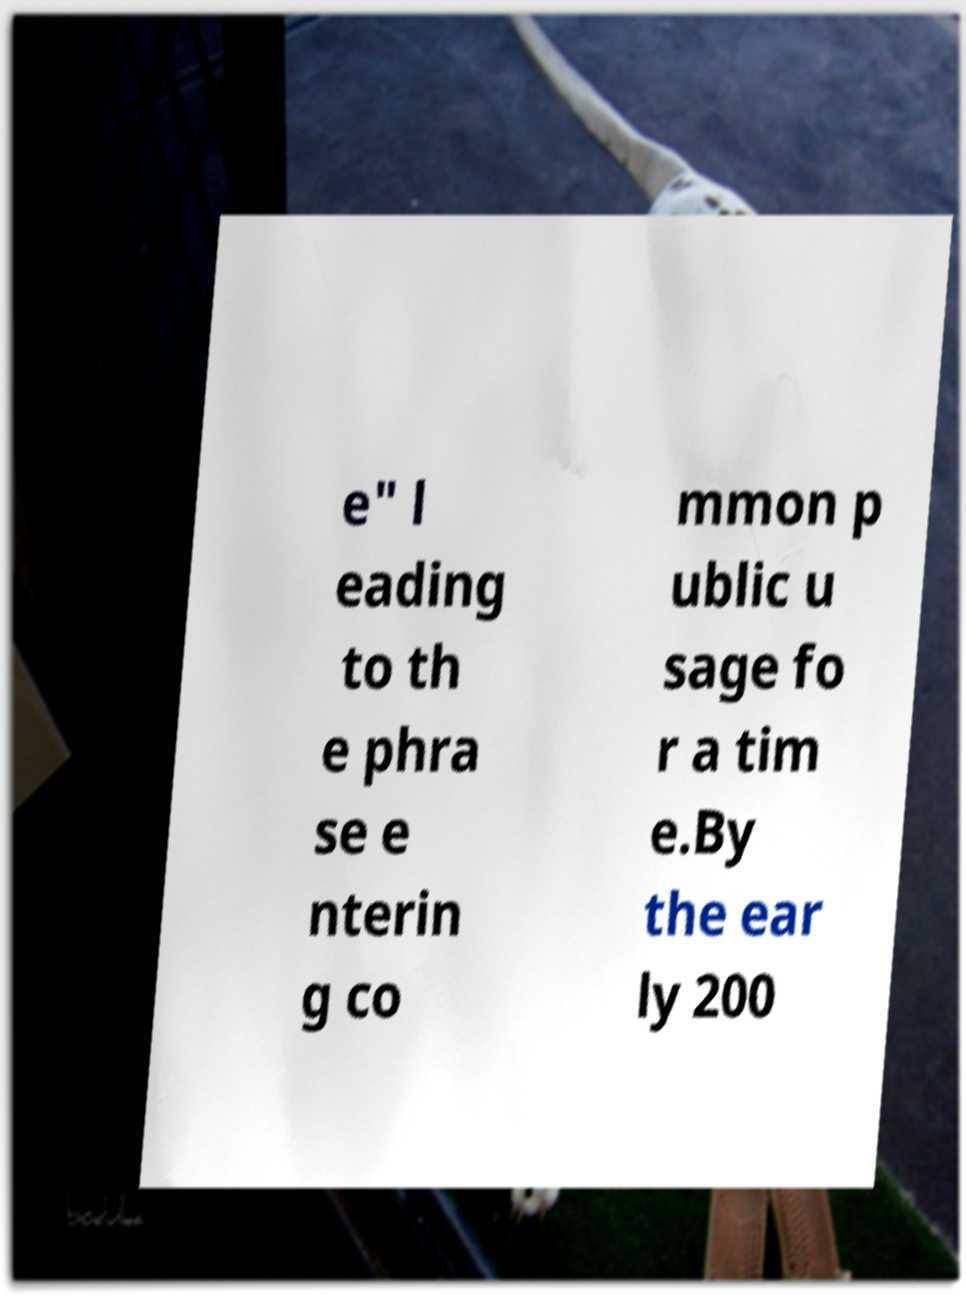Could you extract and type out the text from this image? e" l eading to th e phra se e nterin g co mmon p ublic u sage fo r a tim e.By the ear ly 200 